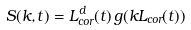<formula> <loc_0><loc_0><loc_500><loc_500>S ( k , t ) = L ^ { d } _ { c o r } ( t ) \, g ( k L _ { c o r } ( t ) )</formula> 